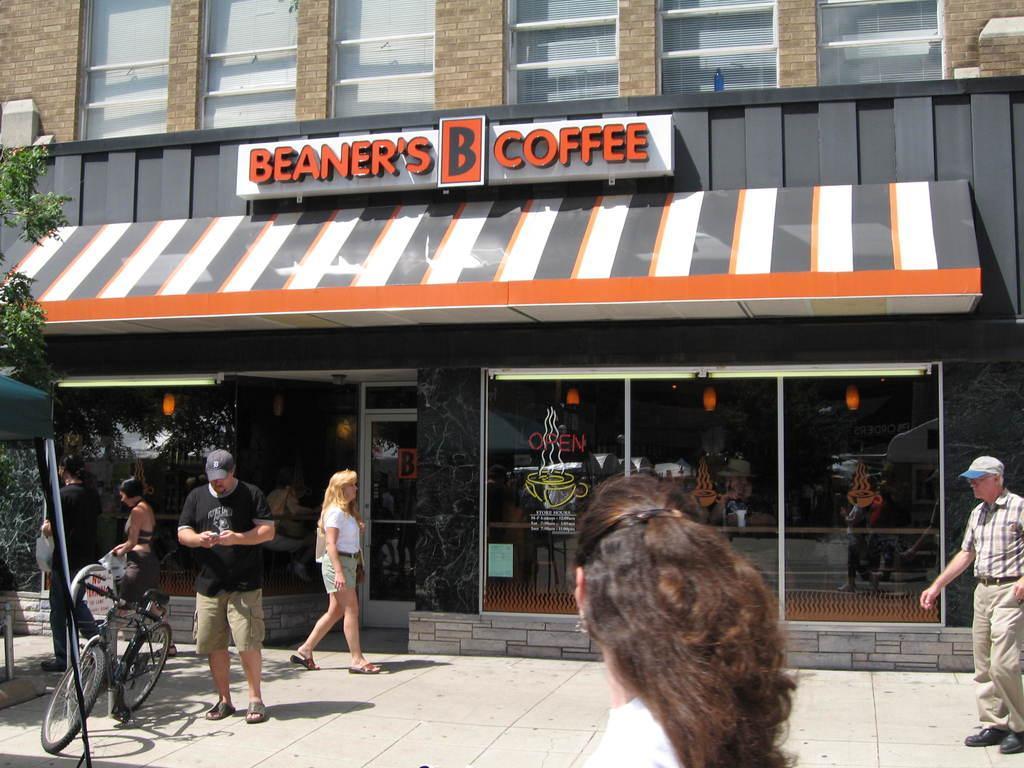In one or two sentences, can you explain what this image depicts? This is the front view of a coffee shop with glass doors and windows, in front of the coffee shop there are a few people walking on the street, there is a bicycle parked in front of the coffee shop. 